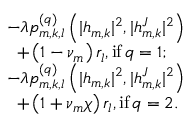Convert formula to latex. <formula><loc_0><loc_0><loc_500><loc_500>\begin{array} { r l } & { - \lambda p _ { m , k , l } ^ { ( q ) } \left ( | h _ { m , k } | ^ { 2 } , | h _ { m , k } ^ { J } | ^ { 2 } \right ) } \\ & { \, + \left ( 1 - \nu _ { m } \right ) r _ { l } , { i f } \, q = 1 ; } \\ & { - \lambda p _ { m , k , l } ^ { ( q ) } \left ( | h _ { m , k } | ^ { 2 } , | h _ { m , k } ^ { J } | ^ { 2 } \right ) } \\ & { \, + \left ( 1 + \nu _ { m } \chi \right ) r _ { l } , { i f } \, q = 2 . } \end{array}</formula> 